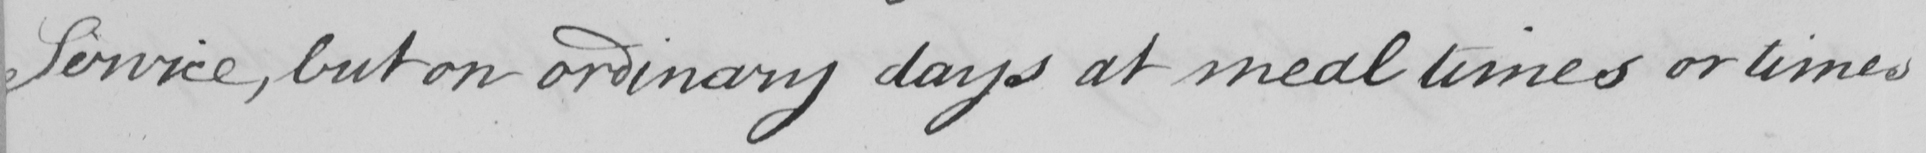What is written in this line of handwriting? Service , but on ordinary days at meal times or times 